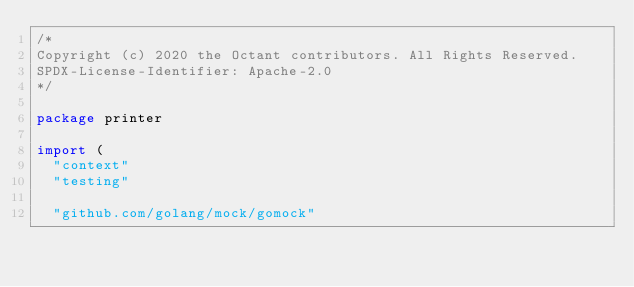<code> <loc_0><loc_0><loc_500><loc_500><_Go_>/*
Copyright (c) 2020 the Octant contributors. All Rights Reserved.
SPDX-License-Identifier: Apache-2.0
*/

package printer

import (
	"context"
	"testing"

	"github.com/golang/mock/gomock"</code> 